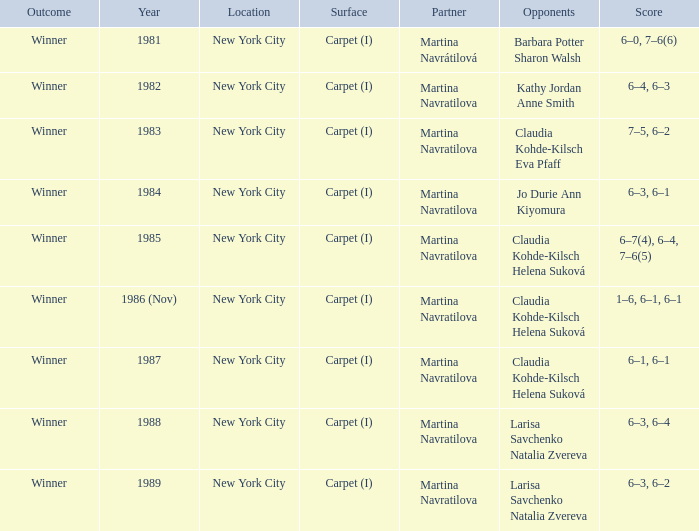What was the outcome for the match in 1989? Winner. 